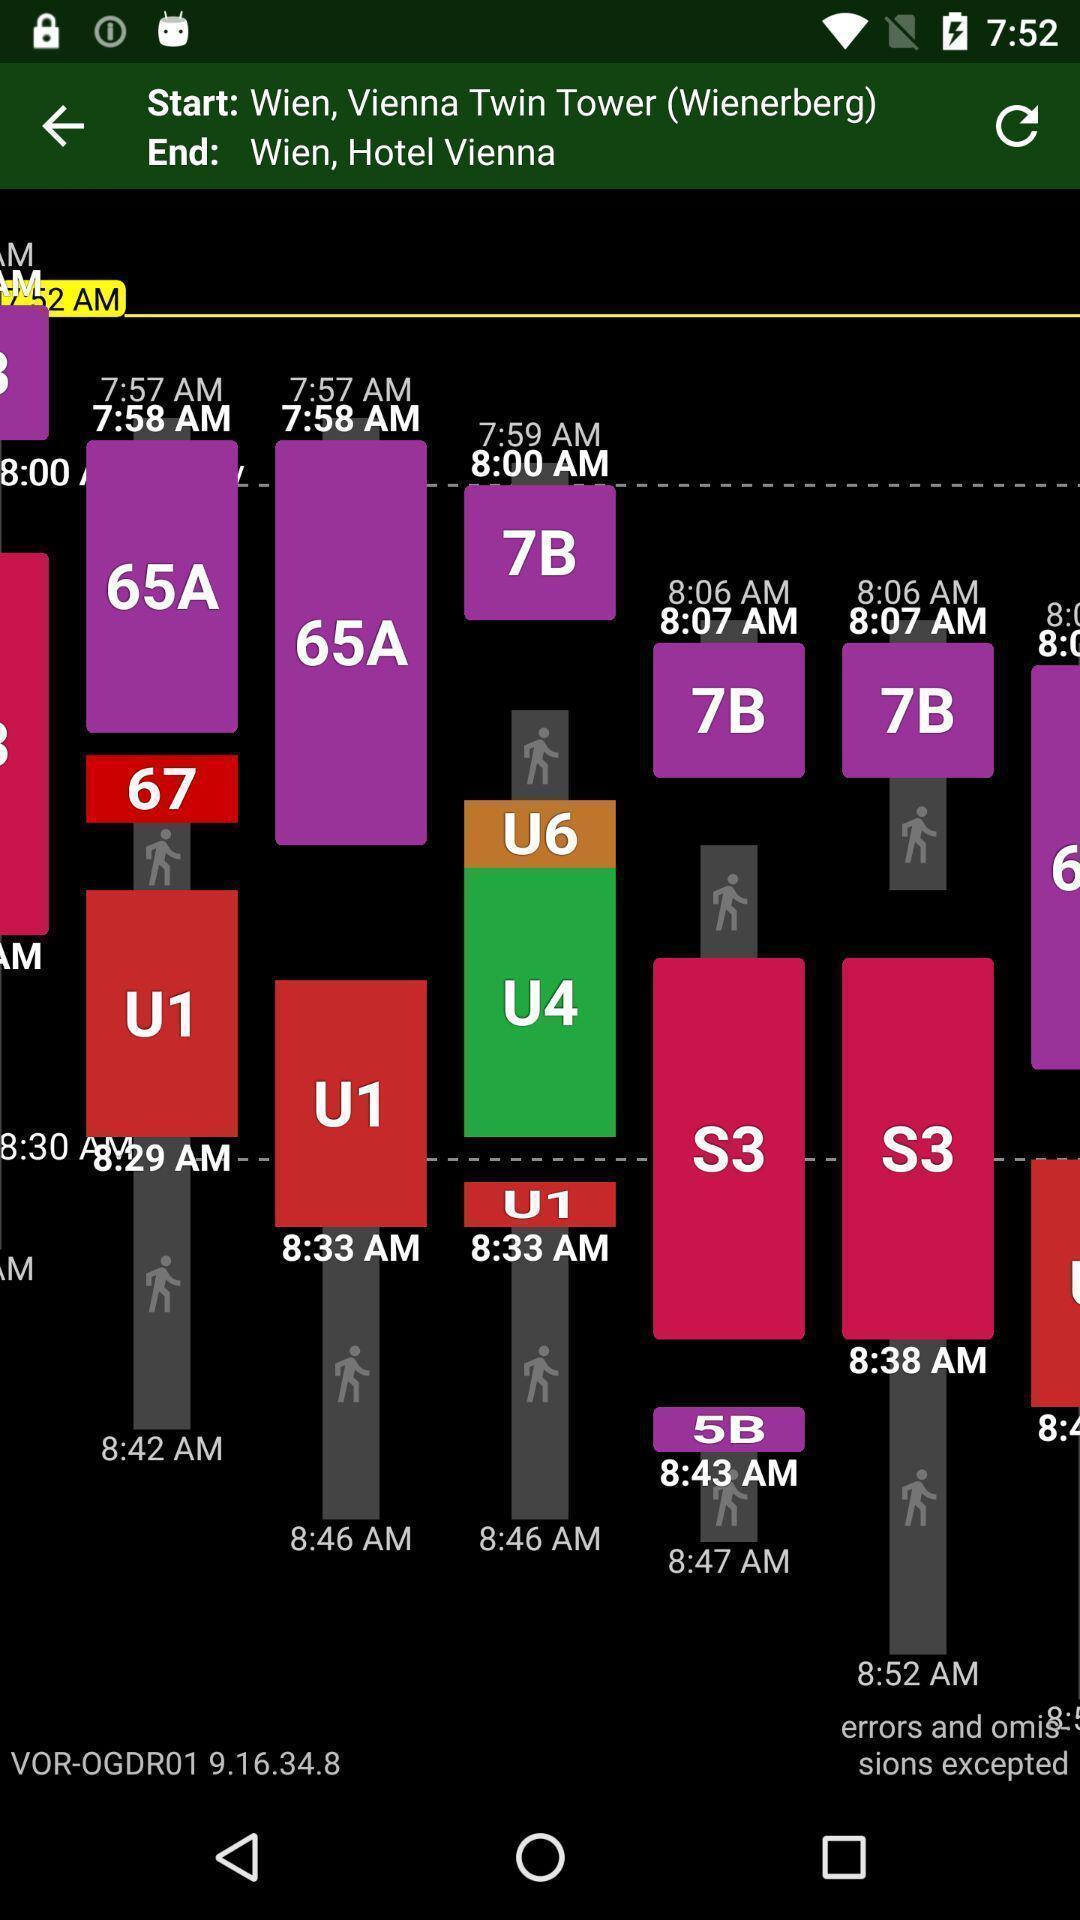Give me a summary of this screen capture. Page displaying start and end time schedules. 